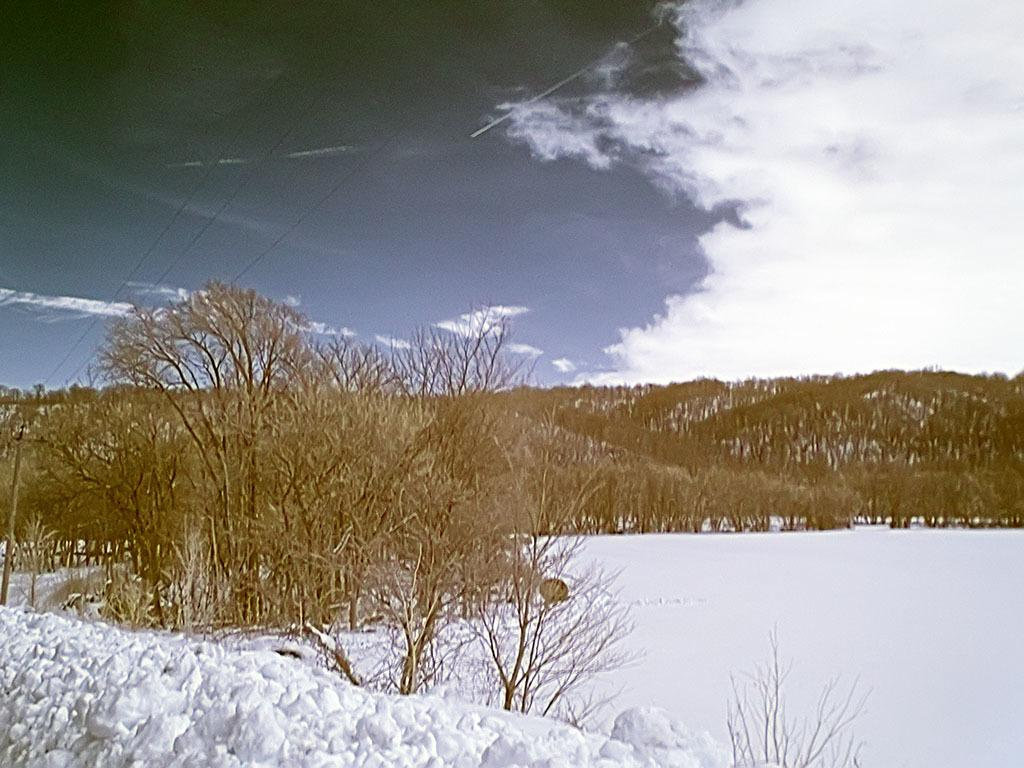What is covering the ground in the image? There is snow on the ground in the image. What type of natural elements can be seen in the image? There are trees in the image. What is attached to the pole in the image? There is a pole with wires in the image. What is visible in the sky in the image? The sky is visible in the image, and clouds are present. How many snakes are slithering through the snow in the image? There are no snakes present in the image; it features snow on the ground, trees, a pole with wires, and a sky with clouds. What type of rings can be seen on the trees in the image? There are no rings visible on the trees in the image; only the trees themselves are present. 